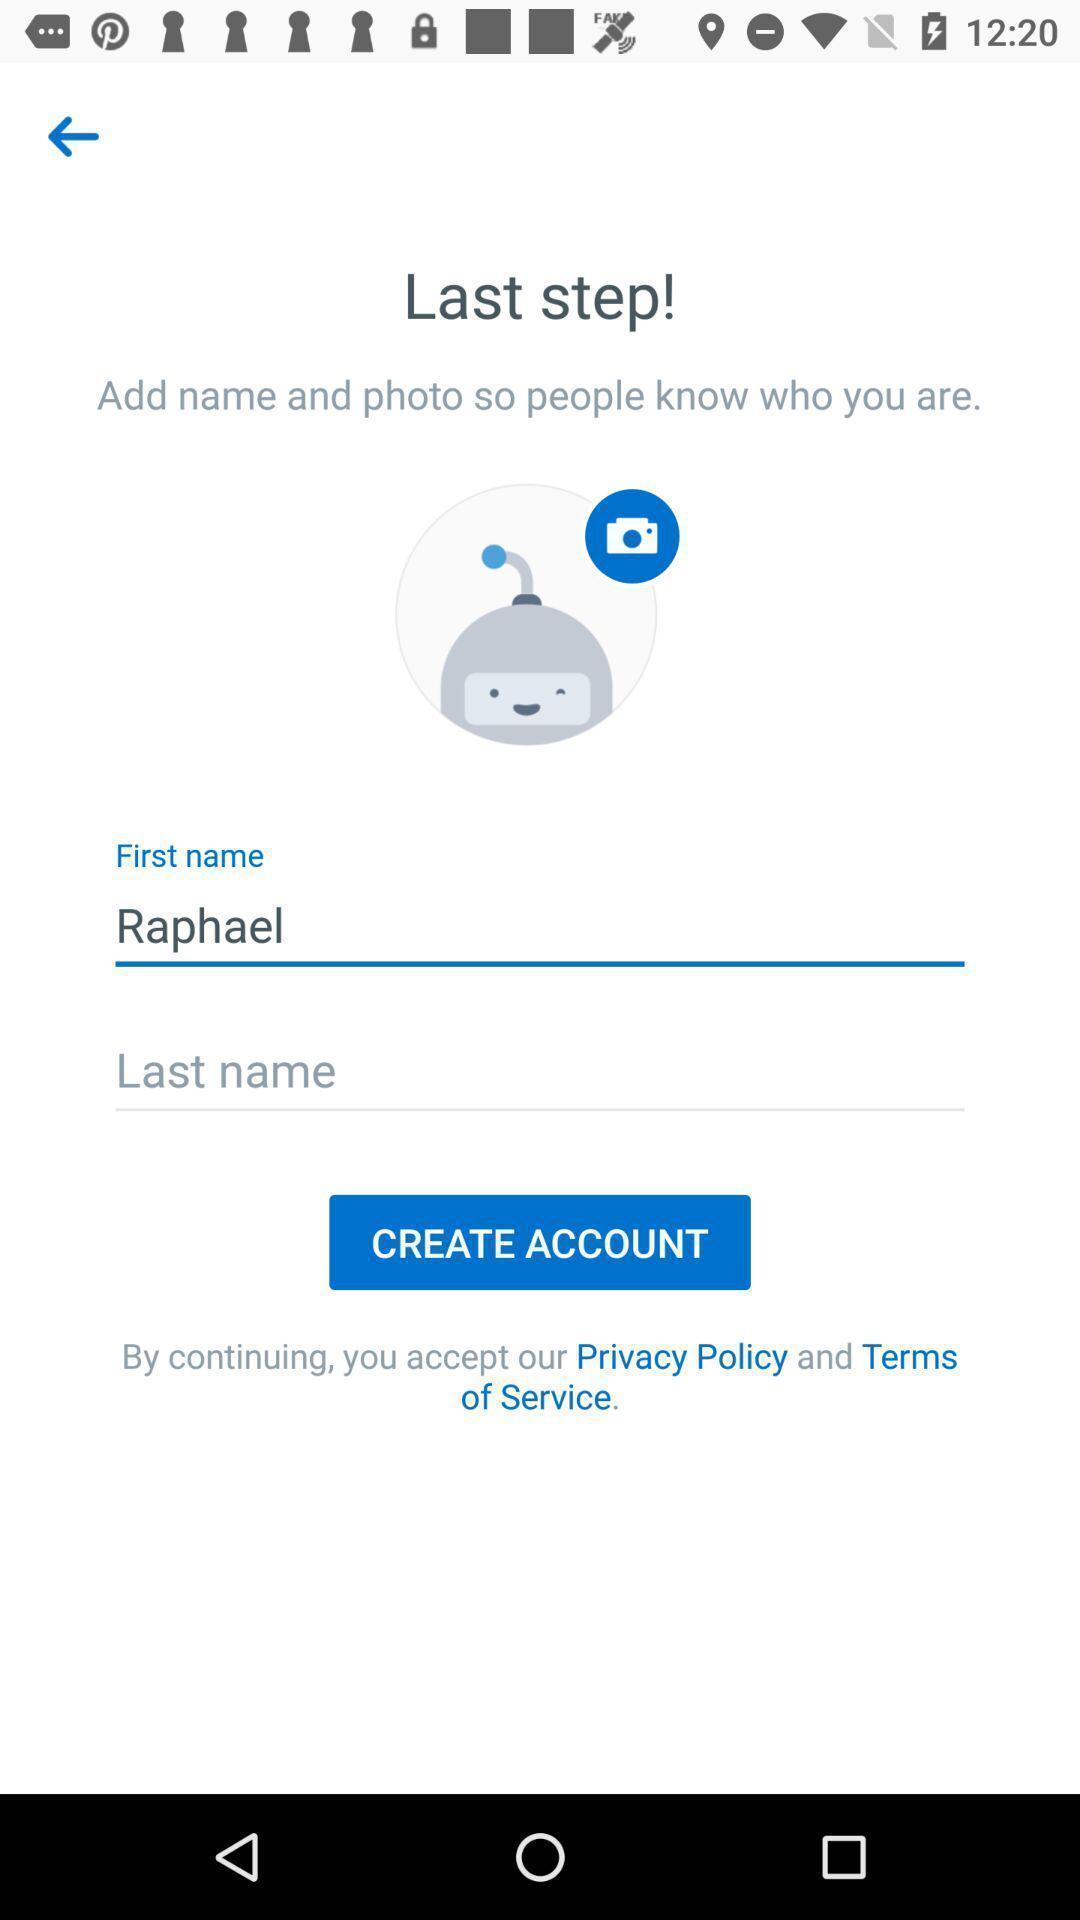Describe the key features of this screenshot. Sign up page. 